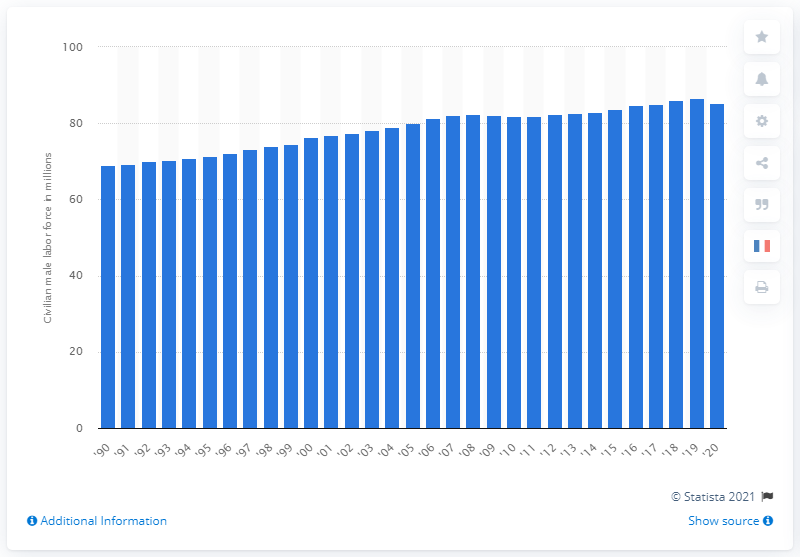Mention a couple of crucial points in this snapshot. In 2020, there were 85.2 million individuals in the United States who were either employed or actively seeking employment. 